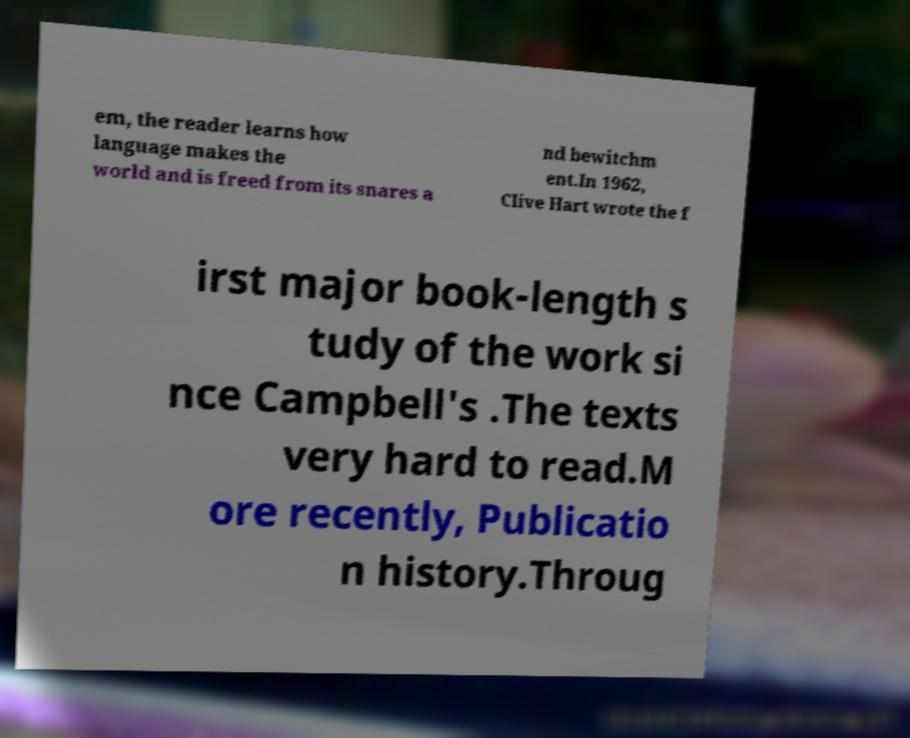Can you accurately transcribe the text from the provided image for me? em, the reader learns how language makes the world and is freed from its snares a nd bewitchm ent.In 1962, Clive Hart wrote the f irst major book-length s tudy of the work si nce Campbell's .The texts very hard to read.M ore recently, Publicatio n history.Throug 